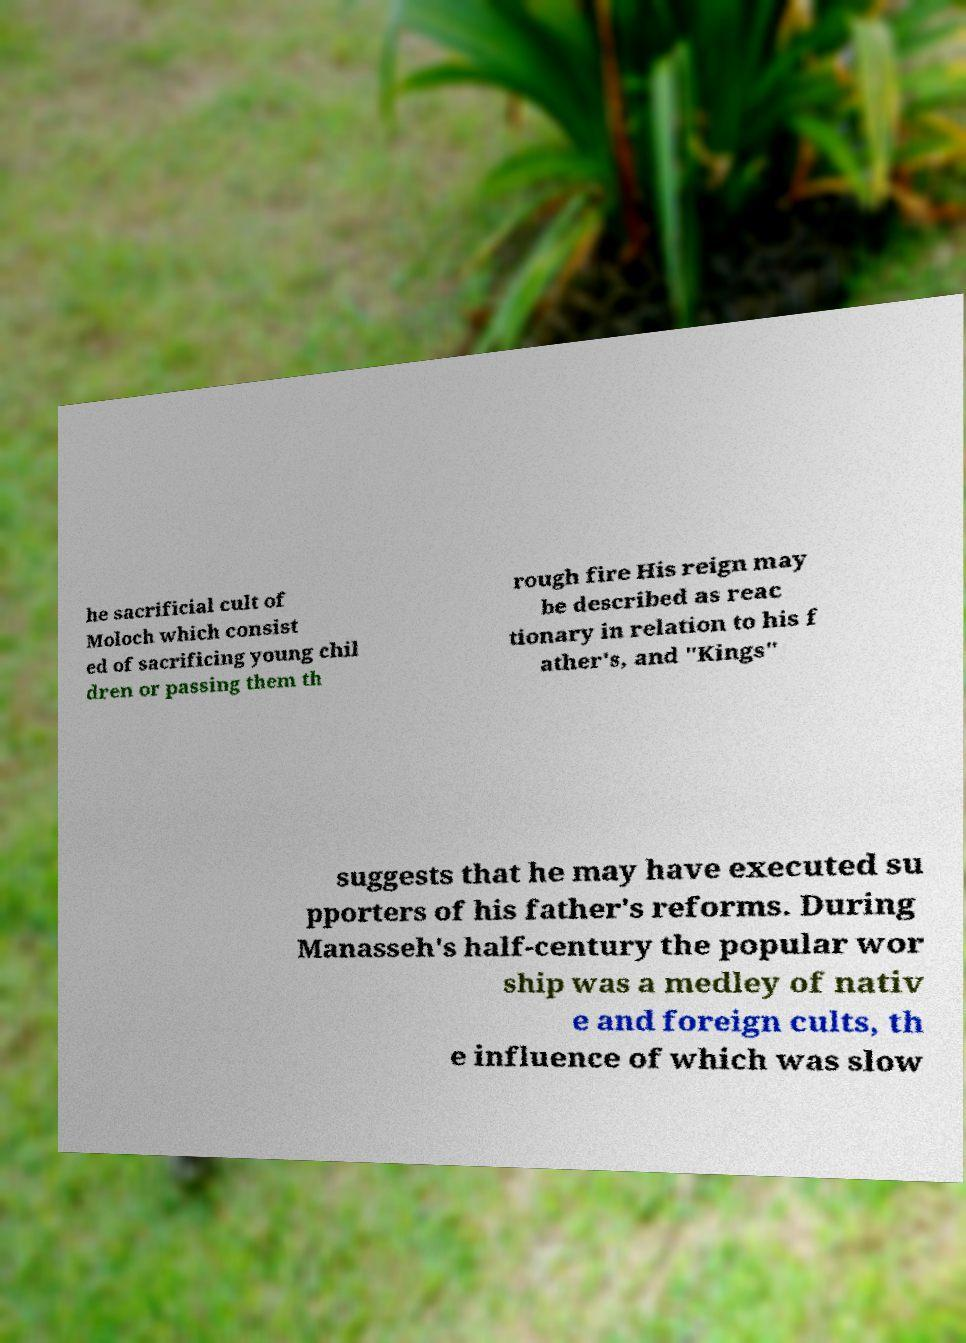Can you read and provide the text displayed in the image?This photo seems to have some interesting text. Can you extract and type it out for me? he sacrificial cult of Moloch which consist ed of sacrificing young chil dren or passing them th rough fire His reign may be described as reac tionary in relation to his f ather's, and "Kings" suggests that he may have executed su pporters of his father's reforms. During Manasseh's half-century the popular wor ship was a medley of nativ e and foreign cults, th e influence of which was slow 